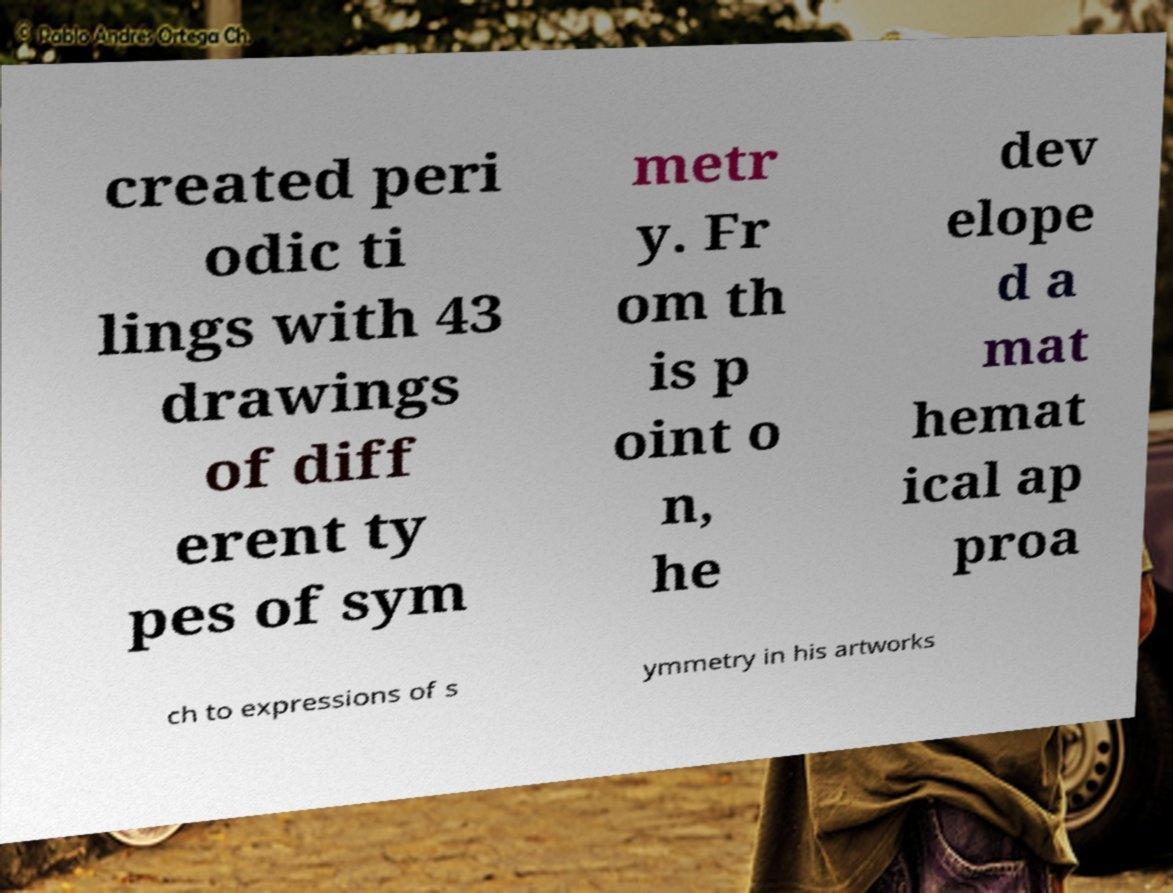Can you read and provide the text displayed in the image?This photo seems to have some interesting text. Can you extract and type it out for me? created peri odic ti lings with 43 drawings of diff erent ty pes of sym metr y. Fr om th is p oint o n, he dev elope d a mat hemat ical ap proa ch to expressions of s ymmetry in his artworks 